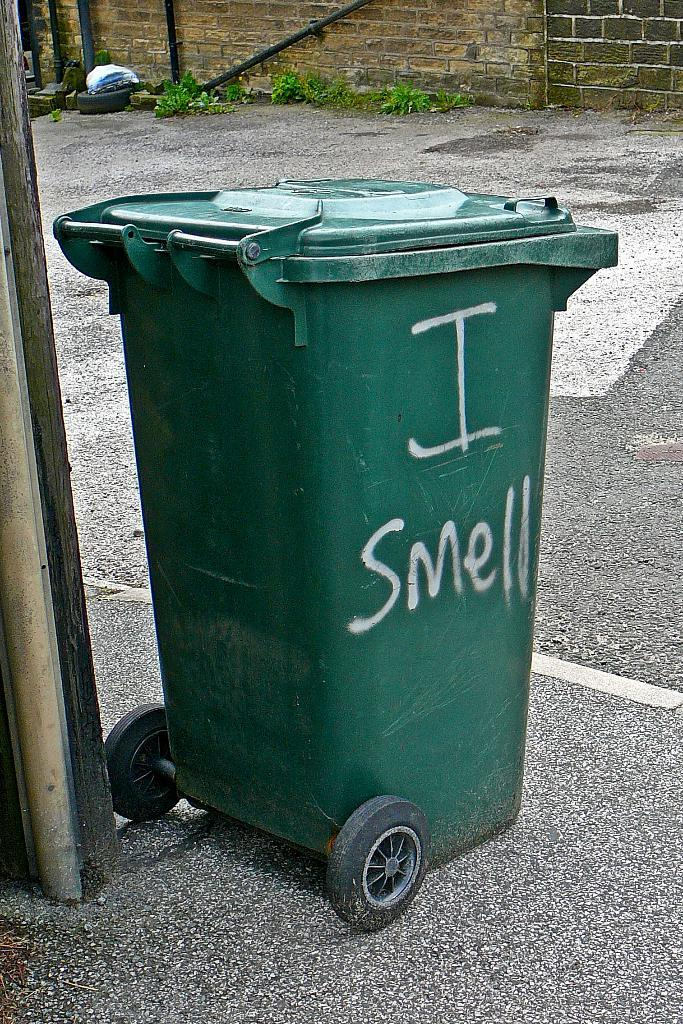<image>
Offer a succinct explanation of the picture presented. A green trash can has the words "I smell" written on the side. 